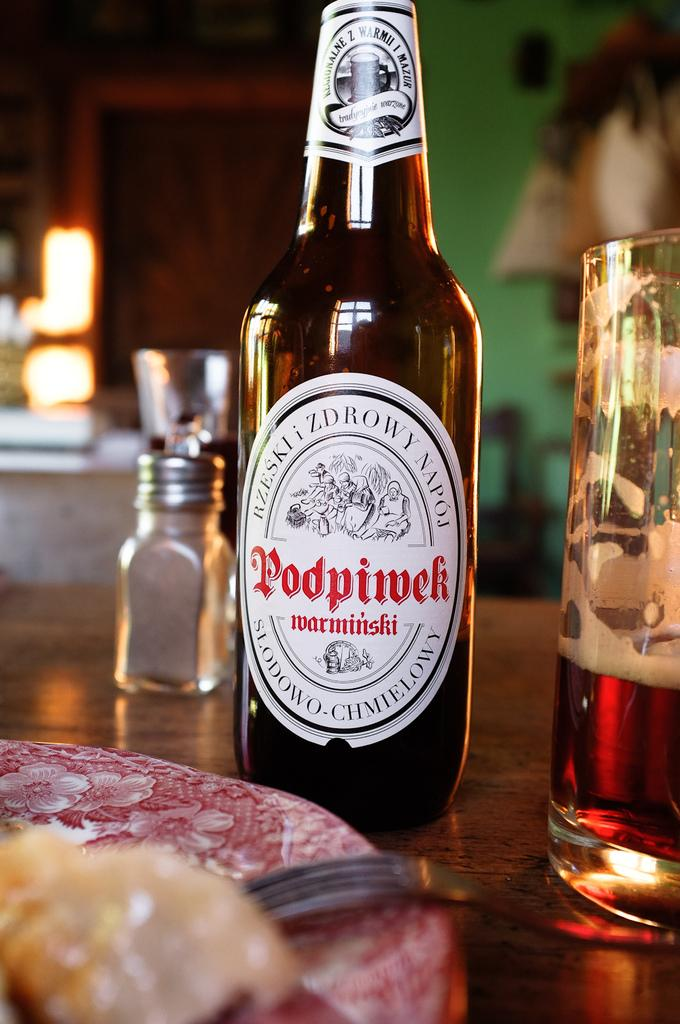<image>
Provide a brief description of the given image. A bottle of a polish Podpiwek beer is next to a half empty glass. 